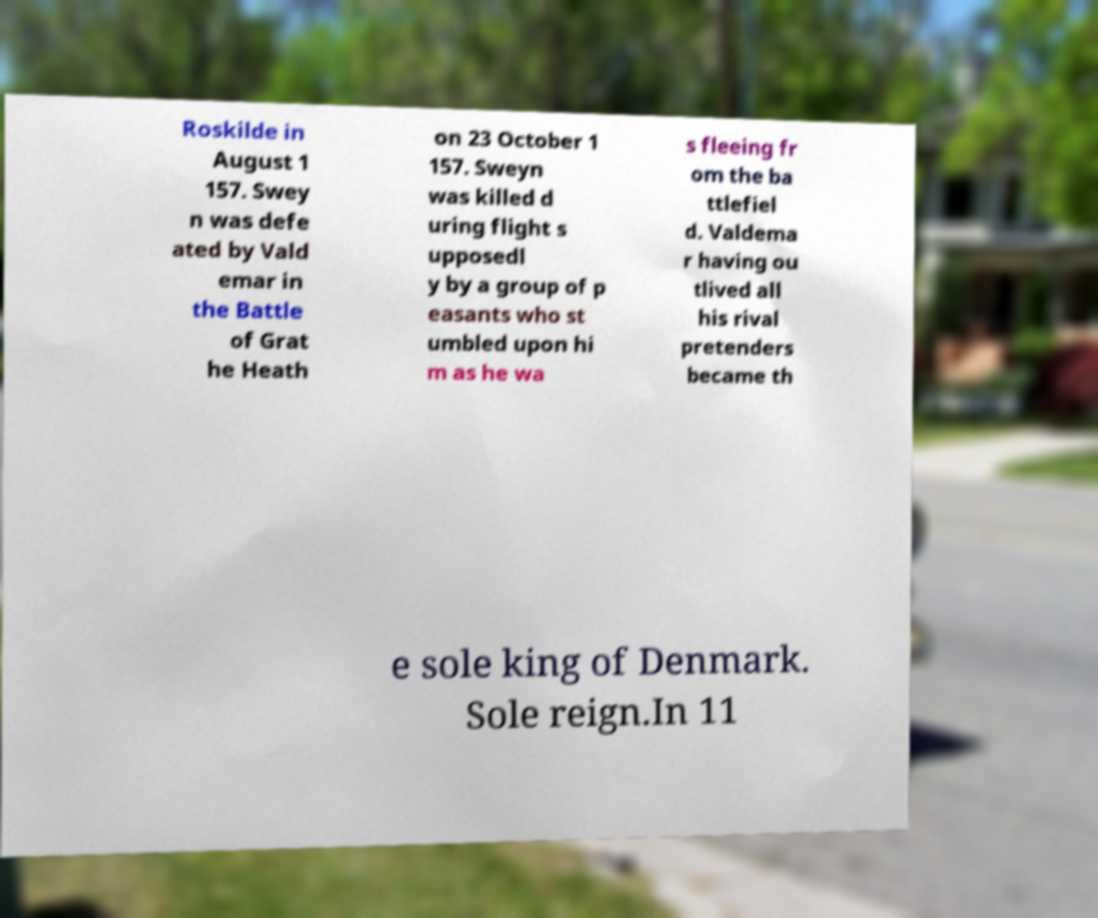For documentation purposes, I need the text within this image transcribed. Could you provide that? Roskilde in August 1 157. Swey n was defe ated by Vald emar in the Battle of Grat he Heath on 23 October 1 157. Sweyn was killed d uring flight s upposedl y by a group of p easants who st umbled upon hi m as he wa s fleeing fr om the ba ttlefiel d. Valdema r having ou tlived all his rival pretenders became th e sole king of Denmark. Sole reign.In 11 